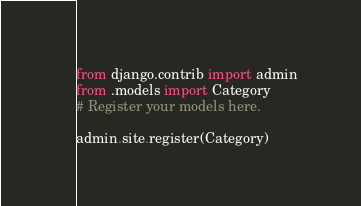Convert code to text. <code><loc_0><loc_0><loc_500><loc_500><_Python_>from django.contrib import admin
from .models import Category
# Register your models here.

admin.site.register(Category)
</code> 